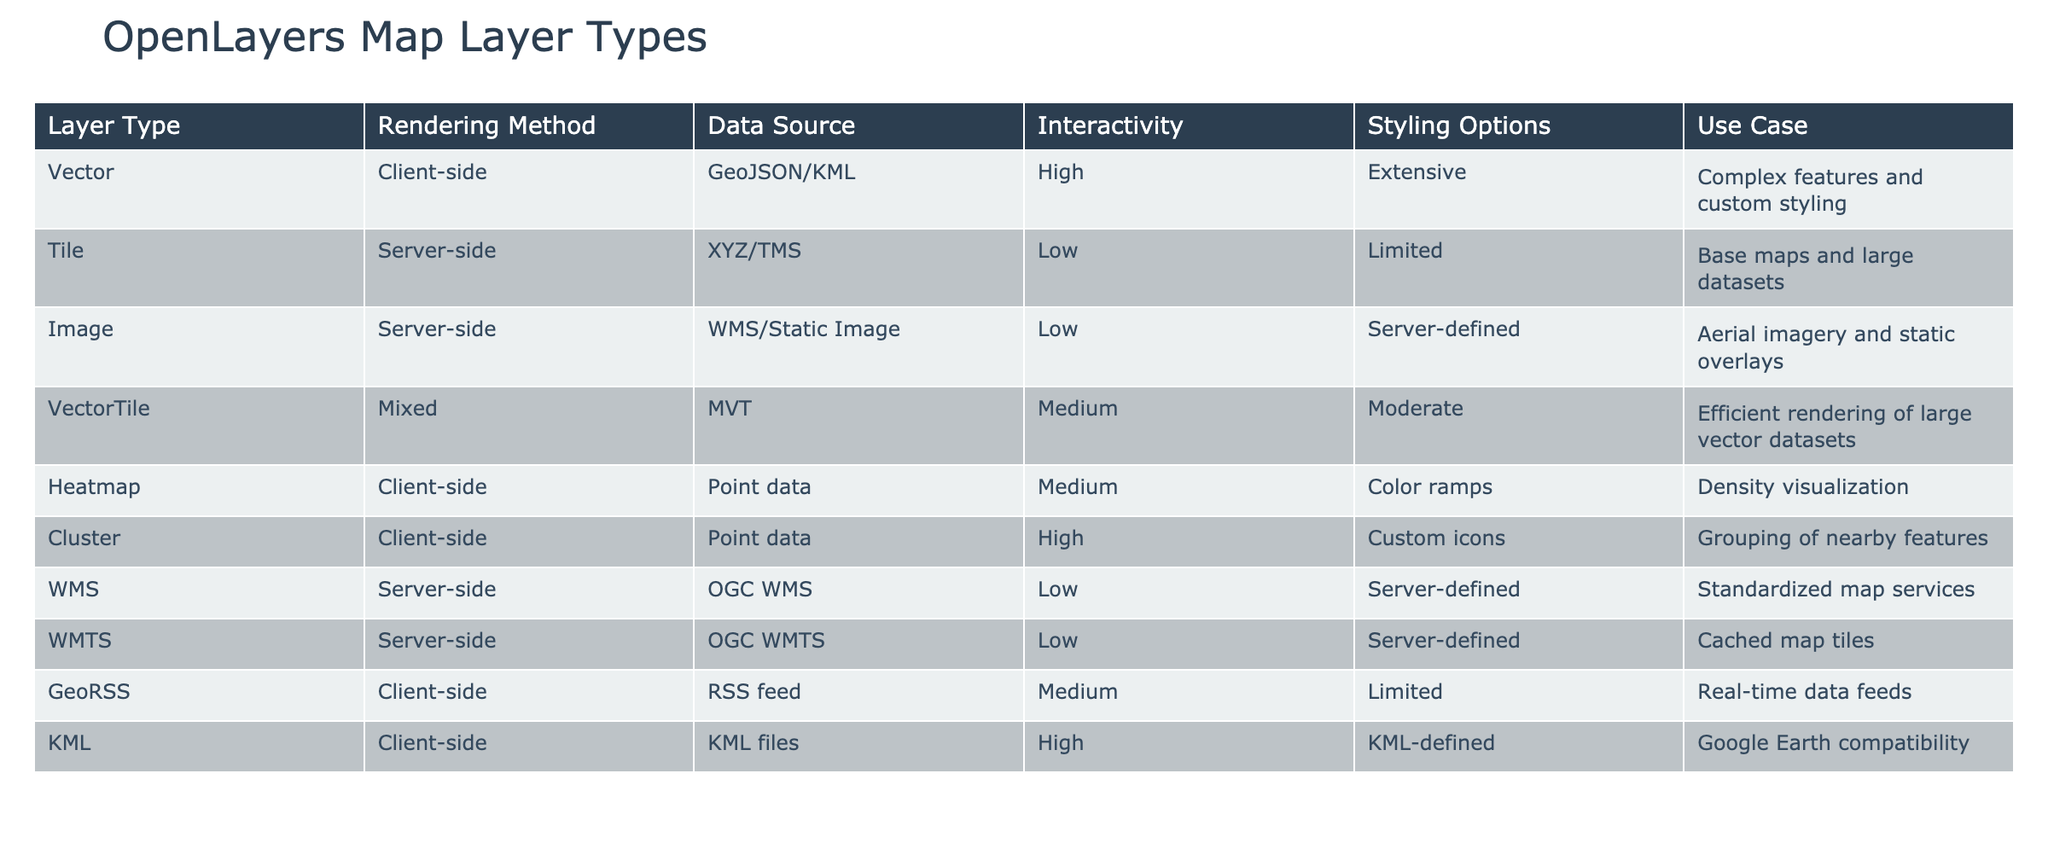What is the rendering method of the Vector layer type? The table lists the Vector layer type's rendering method in the relevant column. According to the table, the rendering method for Vector layers is client-side.
Answer: Client-side Which layer types offer high interactivity? To answer this question, I need to look at the interactivity column and identify all layer types with high interactivity. The table shows that Vector, Cluster, and KML layers have high interactivity.
Answer: Vector, Cluster, KML Is the data source for Heatmap layer type a GeoJSON? Looking at the data source column for the Heatmap layer, it specifies point data as the source, not GeoJSON. Therefore, the answer is based on direct observation of the table.
Answer: No What are the styling options for Tile and Image layer types? I will look at the styling options column to compare the two layer types. The table states that the Tile layer has limited styling options and the Image layer has server-defined options.
Answer: Tile: Limited, Image: Server-defined How many layer types use the client-side rendering method? I need to count the number of layer types with client-side rendering method by checking the rendering method column. The Vector, Heatmap, Cluster, GeoRSS, and KML layers use client-side rendering, totaling five types.
Answer: Five Which layer type has a medium level of interactivity and a data source of point data? From the table, I will examine the interactivity and data source columns to find a match. The Heatmap layer has medium interactivity and a data source of point data.
Answer: Heatmap Are all server-side layers defined by the server as their styling options? Checking the styling options for each server-side layer: Tile, Image, WMS, and WMTS, they are all server-defined. Therefore, the answer is based on reviewing this column.
Answer: Yes What is the difference in interactivity levels between Vector and Tile layer types? I will refer to the interactivity column, noting that Vector has a high interactivity level while Tile has a low level. The difference between high and low indicates a notable disparity in interactivity.
Answer: The difference is significant (high vs. low) 